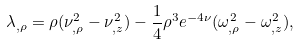<formula> <loc_0><loc_0><loc_500><loc_500>\lambda _ { , \rho } = \rho ( \nu _ { , \rho } ^ { 2 } - \nu _ { , z } ^ { 2 } ) - \frac { 1 } { 4 } \rho ^ { 3 } e ^ { - 4 \nu } ( \omega _ { , \rho } ^ { 2 } - \omega _ { , z } ^ { 2 } ) ,</formula> 